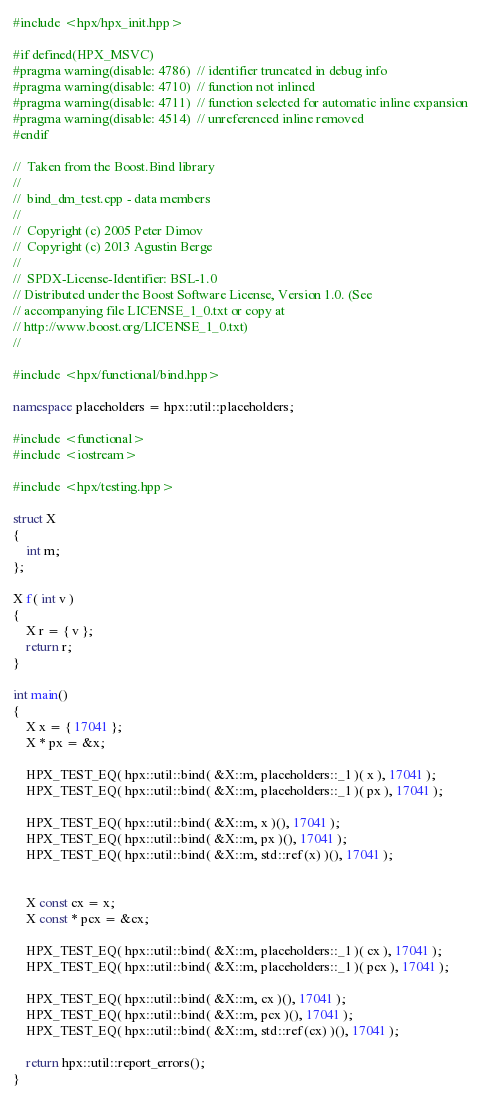Convert code to text. <code><loc_0><loc_0><loc_500><loc_500><_C++_>#include <hpx/hpx_init.hpp>

#if defined(HPX_MSVC)
#pragma warning(disable: 4786)  // identifier truncated in debug info
#pragma warning(disable: 4710)  // function not inlined
#pragma warning(disable: 4711)  // function selected for automatic inline expansion
#pragma warning(disable: 4514)  // unreferenced inline removed
#endif

//  Taken from the Boost.Bind library
//
//  bind_dm_test.cpp - data members
//
//  Copyright (c) 2005 Peter Dimov
//  Copyright (c) 2013 Agustin Berge
//
//  SPDX-License-Identifier: BSL-1.0
// Distributed under the Boost Software License, Version 1.0. (See
// accompanying file LICENSE_1_0.txt or copy at
// http://www.boost.org/LICENSE_1_0.txt)
//

#include <hpx/functional/bind.hpp>

namespace placeholders = hpx::util::placeholders;

#include <functional>
#include <iostream>

#include <hpx/testing.hpp>

struct X
{
    int m;
};

X f( int v )
{
    X r = { v };
    return r;
}

int main()
{
    X x = { 17041 };
    X * px = &x;

    HPX_TEST_EQ( hpx::util::bind( &X::m, placeholders::_1 )( x ), 17041 );
    HPX_TEST_EQ( hpx::util::bind( &X::m, placeholders::_1 )( px ), 17041 );

    HPX_TEST_EQ( hpx::util::bind( &X::m, x )(), 17041 );
    HPX_TEST_EQ( hpx::util::bind( &X::m, px )(), 17041 );
    HPX_TEST_EQ( hpx::util::bind( &X::m, std::ref(x) )(), 17041 );


    X const cx = x;
    X const * pcx = &cx;

    HPX_TEST_EQ( hpx::util::bind( &X::m, placeholders::_1 )( cx ), 17041 );
    HPX_TEST_EQ( hpx::util::bind( &X::m, placeholders::_1 )( pcx ), 17041 );

    HPX_TEST_EQ( hpx::util::bind( &X::m, cx )(), 17041 );
    HPX_TEST_EQ( hpx::util::bind( &X::m, pcx )(), 17041 );
    HPX_TEST_EQ( hpx::util::bind( &X::m, std::ref(cx) )(), 17041 );

    return hpx::util::report_errors();
}
</code> 